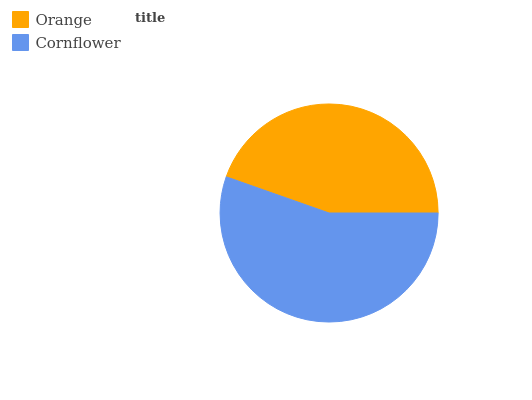Is Orange the minimum?
Answer yes or no. Yes. Is Cornflower the maximum?
Answer yes or no. Yes. Is Cornflower the minimum?
Answer yes or no. No. Is Cornflower greater than Orange?
Answer yes or no. Yes. Is Orange less than Cornflower?
Answer yes or no. Yes. Is Orange greater than Cornflower?
Answer yes or no. No. Is Cornflower less than Orange?
Answer yes or no. No. Is Cornflower the high median?
Answer yes or no. Yes. Is Orange the low median?
Answer yes or no. Yes. Is Orange the high median?
Answer yes or no. No. Is Cornflower the low median?
Answer yes or no. No. 